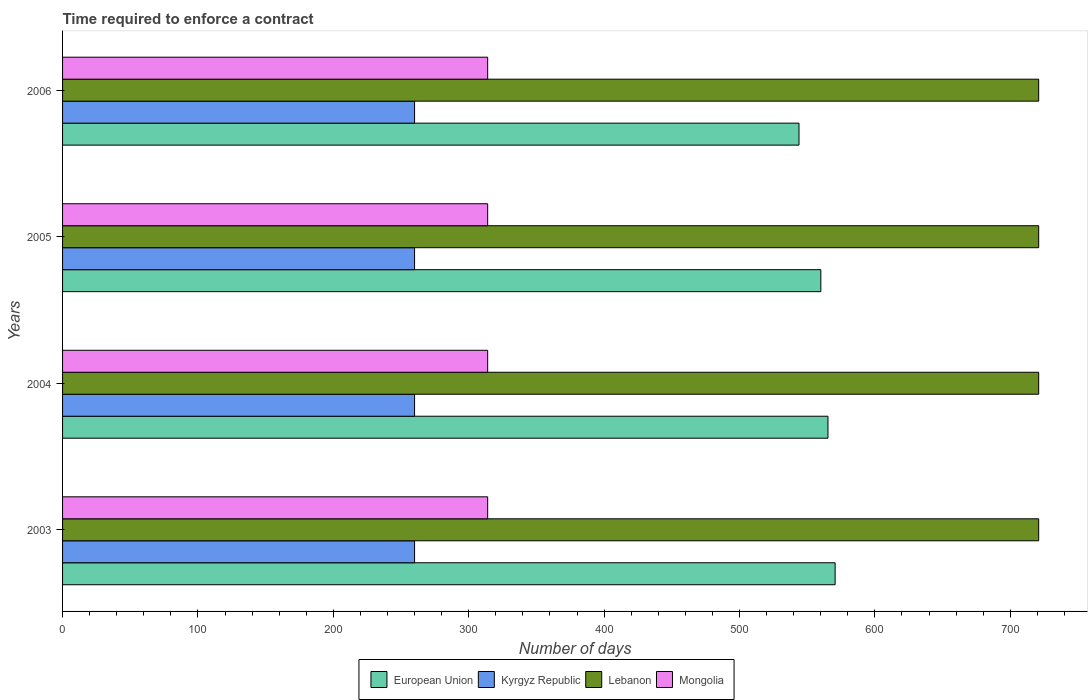How many different coloured bars are there?
Your answer should be very brief. 4. Are the number of bars per tick equal to the number of legend labels?
Your response must be concise. Yes. How many bars are there on the 4th tick from the bottom?
Make the answer very short. 4. What is the label of the 3rd group of bars from the top?
Ensure brevity in your answer.  2004. What is the number of days required to enforce a contract in European Union in 2005?
Your answer should be compact. 560.08. Across all years, what is the maximum number of days required to enforce a contract in European Union?
Make the answer very short. 570.64. Across all years, what is the minimum number of days required to enforce a contract in European Union?
Ensure brevity in your answer.  543.96. What is the total number of days required to enforce a contract in Lebanon in the graph?
Give a very brief answer. 2884. What is the difference between the number of days required to enforce a contract in European Union in 2003 and that in 2005?
Ensure brevity in your answer.  10.56. What is the difference between the number of days required to enforce a contract in Mongolia in 2006 and the number of days required to enforce a contract in European Union in 2003?
Keep it short and to the point. -256.64. What is the average number of days required to enforce a contract in European Union per year?
Your answer should be very brief. 560.01. In the year 2003, what is the difference between the number of days required to enforce a contract in Kyrgyz Republic and number of days required to enforce a contract in European Union?
Provide a succinct answer. -310.64. In how many years, is the number of days required to enforce a contract in European Union greater than 480 days?
Your answer should be compact. 4. Is the difference between the number of days required to enforce a contract in Kyrgyz Republic in 2004 and 2005 greater than the difference between the number of days required to enforce a contract in European Union in 2004 and 2005?
Offer a very short reply. No. What is the difference between the highest and the second highest number of days required to enforce a contract in Lebanon?
Your answer should be very brief. 0. What is the difference between the highest and the lowest number of days required to enforce a contract in Lebanon?
Give a very brief answer. 0. Is the sum of the number of days required to enforce a contract in Lebanon in 2003 and 2006 greater than the maximum number of days required to enforce a contract in Mongolia across all years?
Keep it short and to the point. Yes. Is it the case that in every year, the sum of the number of days required to enforce a contract in Kyrgyz Republic and number of days required to enforce a contract in Mongolia is greater than the sum of number of days required to enforce a contract in Lebanon and number of days required to enforce a contract in European Union?
Provide a succinct answer. No. What does the 2nd bar from the bottom in 2003 represents?
Give a very brief answer. Kyrgyz Republic. How many bars are there?
Ensure brevity in your answer.  16. Are all the bars in the graph horizontal?
Make the answer very short. Yes. How many years are there in the graph?
Offer a very short reply. 4. What is the difference between two consecutive major ticks on the X-axis?
Offer a very short reply. 100. Are the values on the major ticks of X-axis written in scientific E-notation?
Keep it short and to the point. No. How many legend labels are there?
Keep it short and to the point. 4. How are the legend labels stacked?
Make the answer very short. Horizontal. What is the title of the graph?
Your response must be concise. Time required to enforce a contract. What is the label or title of the X-axis?
Make the answer very short. Number of days. What is the label or title of the Y-axis?
Make the answer very short. Years. What is the Number of days in European Union in 2003?
Ensure brevity in your answer.  570.64. What is the Number of days of Kyrgyz Republic in 2003?
Offer a terse response. 260. What is the Number of days of Lebanon in 2003?
Provide a succinct answer. 721. What is the Number of days in Mongolia in 2003?
Your response must be concise. 314. What is the Number of days in European Union in 2004?
Provide a short and direct response. 565.36. What is the Number of days in Kyrgyz Republic in 2004?
Make the answer very short. 260. What is the Number of days in Lebanon in 2004?
Give a very brief answer. 721. What is the Number of days in Mongolia in 2004?
Your response must be concise. 314. What is the Number of days in European Union in 2005?
Provide a succinct answer. 560.08. What is the Number of days in Kyrgyz Republic in 2005?
Your response must be concise. 260. What is the Number of days in Lebanon in 2005?
Make the answer very short. 721. What is the Number of days in Mongolia in 2005?
Give a very brief answer. 314. What is the Number of days in European Union in 2006?
Provide a succinct answer. 543.96. What is the Number of days in Kyrgyz Republic in 2006?
Ensure brevity in your answer.  260. What is the Number of days of Lebanon in 2006?
Make the answer very short. 721. What is the Number of days of Mongolia in 2006?
Offer a very short reply. 314. Across all years, what is the maximum Number of days in European Union?
Your answer should be compact. 570.64. Across all years, what is the maximum Number of days of Kyrgyz Republic?
Give a very brief answer. 260. Across all years, what is the maximum Number of days of Lebanon?
Provide a short and direct response. 721. Across all years, what is the maximum Number of days in Mongolia?
Keep it short and to the point. 314. Across all years, what is the minimum Number of days of European Union?
Your answer should be very brief. 543.96. Across all years, what is the minimum Number of days in Kyrgyz Republic?
Offer a very short reply. 260. Across all years, what is the minimum Number of days of Lebanon?
Your answer should be very brief. 721. Across all years, what is the minimum Number of days of Mongolia?
Your response must be concise. 314. What is the total Number of days of European Union in the graph?
Your answer should be compact. 2240.04. What is the total Number of days of Kyrgyz Republic in the graph?
Provide a succinct answer. 1040. What is the total Number of days of Lebanon in the graph?
Provide a short and direct response. 2884. What is the total Number of days in Mongolia in the graph?
Provide a short and direct response. 1256. What is the difference between the Number of days in European Union in 2003 and that in 2004?
Make the answer very short. 5.28. What is the difference between the Number of days in Kyrgyz Republic in 2003 and that in 2004?
Offer a terse response. 0. What is the difference between the Number of days of Lebanon in 2003 and that in 2004?
Offer a very short reply. 0. What is the difference between the Number of days of Mongolia in 2003 and that in 2004?
Your answer should be compact. 0. What is the difference between the Number of days of European Union in 2003 and that in 2005?
Ensure brevity in your answer.  10.56. What is the difference between the Number of days in Lebanon in 2003 and that in 2005?
Your answer should be compact. 0. What is the difference between the Number of days of European Union in 2003 and that in 2006?
Offer a terse response. 26.68. What is the difference between the Number of days in European Union in 2004 and that in 2005?
Offer a very short reply. 5.28. What is the difference between the Number of days in Kyrgyz Republic in 2004 and that in 2005?
Offer a very short reply. 0. What is the difference between the Number of days of Lebanon in 2004 and that in 2005?
Give a very brief answer. 0. What is the difference between the Number of days of Mongolia in 2004 and that in 2005?
Give a very brief answer. 0. What is the difference between the Number of days in European Union in 2004 and that in 2006?
Keep it short and to the point. 21.4. What is the difference between the Number of days of Kyrgyz Republic in 2004 and that in 2006?
Provide a succinct answer. 0. What is the difference between the Number of days in Mongolia in 2004 and that in 2006?
Offer a very short reply. 0. What is the difference between the Number of days of European Union in 2005 and that in 2006?
Offer a very short reply. 16.12. What is the difference between the Number of days of Lebanon in 2005 and that in 2006?
Give a very brief answer. 0. What is the difference between the Number of days in Mongolia in 2005 and that in 2006?
Make the answer very short. 0. What is the difference between the Number of days of European Union in 2003 and the Number of days of Kyrgyz Republic in 2004?
Give a very brief answer. 310.64. What is the difference between the Number of days in European Union in 2003 and the Number of days in Lebanon in 2004?
Your response must be concise. -150.36. What is the difference between the Number of days of European Union in 2003 and the Number of days of Mongolia in 2004?
Offer a very short reply. 256.64. What is the difference between the Number of days of Kyrgyz Republic in 2003 and the Number of days of Lebanon in 2004?
Provide a short and direct response. -461. What is the difference between the Number of days in Kyrgyz Republic in 2003 and the Number of days in Mongolia in 2004?
Make the answer very short. -54. What is the difference between the Number of days of Lebanon in 2003 and the Number of days of Mongolia in 2004?
Give a very brief answer. 407. What is the difference between the Number of days of European Union in 2003 and the Number of days of Kyrgyz Republic in 2005?
Provide a succinct answer. 310.64. What is the difference between the Number of days of European Union in 2003 and the Number of days of Lebanon in 2005?
Make the answer very short. -150.36. What is the difference between the Number of days of European Union in 2003 and the Number of days of Mongolia in 2005?
Ensure brevity in your answer.  256.64. What is the difference between the Number of days of Kyrgyz Republic in 2003 and the Number of days of Lebanon in 2005?
Offer a terse response. -461. What is the difference between the Number of days of Kyrgyz Republic in 2003 and the Number of days of Mongolia in 2005?
Provide a short and direct response. -54. What is the difference between the Number of days in Lebanon in 2003 and the Number of days in Mongolia in 2005?
Give a very brief answer. 407. What is the difference between the Number of days in European Union in 2003 and the Number of days in Kyrgyz Republic in 2006?
Provide a short and direct response. 310.64. What is the difference between the Number of days of European Union in 2003 and the Number of days of Lebanon in 2006?
Ensure brevity in your answer.  -150.36. What is the difference between the Number of days of European Union in 2003 and the Number of days of Mongolia in 2006?
Your response must be concise. 256.64. What is the difference between the Number of days in Kyrgyz Republic in 2003 and the Number of days in Lebanon in 2006?
Ensure brevity in your answer.  -461. What is the difference between the Number of days in Kyrgyz Republic in 2003 and the Number of days in Mongolia in 2006?
Your response must be concise. -54. What is the difference between the Number of days of Lebanon in 2003 and the Number of days of Mongolia in 2006?
Your answer should be very brief. 407. What is the difference between the Number of days in European Union in 2004 and the Number of days in Kyrgyz Republic in 2005?
Offer a terse response. 305.36. What is the difference between the Number of days of European Union in 2004 and the Number of days of Lebanon in 2005?
Ensure brevity in your answer.  -155.64. What is the difference between the Number of days of European Union in 2004 and the Number of days of Mongolia in 2005?
Provide a short and direct response. 251.36. What is the difference between the Number of days in Kyrgyz Republic in 2004 and the Number of days in Lebanon in 2005?
Ensure brevity in your answer.  -461. What is the difference between the Number of days of Kyrgyz Republic in 2004 and the Number of days of Mongolia in 2005?
Provide a succinct answer. -54. What is the difference between the Number of days of Lebanon in 2004 and the Number of days of Mongolia in 2005?
Provide a short and direct response. 407. What is the difference between the Number of days in European Union in 2004 and the Number of days in Kyrgyz Republic in 2006?
Offer a very short reply. 305.36. What is the difference between the Number of days in European Union in 2004 and the Number of days in Lebanon in 2006?
Provide a succinct answer. -155.64. What is the difference between the Number of days of European Union in 2004 and the Number of days of Mongolia in 2006?
Provide a short and direct response. 251.36. What is the difference between the Number of days in Kyrgyz Republic in 2004 and the Number of days in Lebanon in 2006?
Provide a succinct answer. -461. What is the difference between the Number of days of Kyrgyz Republic in 2004 and the Number of days of Mongolia in 2006?
Ensure brevity in your answer.  -54. What is the difference between the Number of days in Lebanon in 2004 and the Number of days in Mongolia in 2006?
Your response must be concise. 407. What is the difference between the Number of days in European Union in 2005 and the Number of days in Kyrgyz Republic in 2006?
Offer a terse response. 300.08. What is the difference between the Number of days in European Union in 2005 and the Number of days in Lebanon in 2006?
Offer a very short reply. -160.92. What is the difference between the Number of days in European Union in 2005 and the Number of days in Mongolia in 2006?
Your response must be concise. 246.08. What is the difference between the Number of days in Kyrgyz Republic in 2005 and the Number of days in Lebanon in 2006?
Give a very brief answer. -461. What is the difference between the Number of days of Kyrgyz Republic in 2005 and the Number of days of Mongolia in 2006?
Keep it short and to the point. -54. What is the difference between the Number of days of Lebanon in 2005 and the Number of days of Mongolia in 2006?
Offer a terse response. 407. What is the average Number of days of European Union per year?
Give a very brief answer. 560.01. What is the average Number of days in Kyrgyz Republic per year?
Make the answer very short. 260. What is the average Number of days of Lebanon per year?
Your answer should be very brief. 721. What is the average Number of days in Mongolia per year?
Give a very brief answer. 314. In the year 2003, what is the difference between the Number of days of European Union and Number of days of Kyrgyz Republic?
Provide a short and direct response. 310.64. In the year 2003, what is the difference between the Number of days in European Union and Number of days in Lebanon?
Offer a very short reply. -150.36. In the year 2003, what is the difference between the Number of days of European Union and Number of days of Mongolia?
Your answer should be compact. 256.64. In the year 2003, what is the difference between the Number of days in Kyrgyz Republic and Number of days in Lebanon?
Make the answer very short. -461. In the year 2003, what is the difference between the Number of days of Kyrgyz Republic and Number of days of Mongolia?
Offer a very short reply. -54. In the year 2003, what is the difference between the Number of days in Lebanon and Number of days in Mongolia?
Make the answer very short. 407. In the year 2004, what is the difference between the Number of days in European Union and Number of days in Kyrgyz Republic?
Keep it short and to the point. 305.36. In the year 2004, what is the difference between the Number of days in European Union and Number of days in Lebanon?
Provide a short and direct response. -155.64. In the year 2004, what is the difference between the Number of days of European Union and Number of days of Mongolia?
Give a very brief answer. 251.36. In the year 2004, what is the difference between the Number of days of Kyrgyz Republic and Number of days of Lebanon?
Offer a very short reply. -461. In the year 2004, what is the difference between the Number of days of Kyrgyz Republic and Number of days of Mongolia?
Make the answer very short. -54. In the year 2004, what is the difference between the Number of days of Lebanon and Number of days of Mongolia?
Keep it short and to the point. 407. In the year 2005, what is the difference between the Number of days of European Union and Number of days of Kyrgyz Republic?
Keep it short and to the point. 300.08. In the year 2005, what is the difference between the Number of days in European Union and Number of days in Lebanon?
Ensure brevity in your answer.  -160.92. In the year 2005, what is the difference between the Number of days in European Union and Number of days in Mongolia?
Provide a succinct answer. 246.08. In the year 2005, what is the difference between the Number of days of Kyrgyz Republic and Number of days of Lebanon?
Your answer should be compact. -461. In the year 2005, what is the difference between the Number of days in Kyrgyz Republic and Number of days in Mongolia?
Keep it short and to the point. -54. In the year 2005, what is the difference between the Number of days in Lebanon and Number of days in Mongolia?
Give a very brief answer. 407. In the year 2006, what is the difference between the Number of days of European Union and Number of days of Kyrgyz Republic?
Keep it short and to the point. 283.96. In the year 2006, what is the difference between the Number of days in European Union and Number of days in Lebanon?
Provide a short and direct response. -177.04. In the year 2006, what is the difference between the Number of days in European Union and Number of days in Mongolia?
Your answer should be very brief. 229.96. In the year 2006, what is the difference between the Number of days in Kyrgyz Republic and Number of days in Lebanon?
Give a very brief answer. -461. In the year 2006, what is the difference between the Number of days in Kyrgyz Republic and Number of days in Mongolia?
Your answer should be compact. -54. In the year 2006, what is the difference between the Number of days of Lebanon and Number of days of Mongolia?
Offer a very short reply. 407. What is the ratio of the Number of days in European Union in 2003 to that in 2004?
Provide a short and direct response. 1.01. What is the ratio of the Number of days in Kyrgyz Republic in 2003 to that in 2004?
Keep it short and to the point. 1. What is the ratio of the Number of days of Lebanon in 2003 to that in 2004?
Offer a very short reply. 1. What is the ratio of the Number of days in Mongolia in 2003 to that in 2004?
Make the answer very short. 1. What is the ratio of the Number of days of European Union in 2003 to that in 2005?
Keep it short and to the point. 1.02. What is the ratio of the Number of days in Mongolia in 2003 to that in 2005?
Your answer should be very brief. 1. What is the ratio of the Number of days in European Union in 2003 to that in 2006?
Provide a succinct answer. 1.05. What is the ratio of the Number of days of Kyrgyz Republic in 2003 to that in 2006?
Keep it short and to the point. 1. What is the ratio of the Number of days of Lebanon in 2003 to that in 2006?
Your answer should be compact. 1. What is the ratio of the Number of days in Mongolia in 2003 to that in 2006?
Your answer should be compact. 1. What is the ratio of the Number of days in European Union in 2004 to that in 2005?
Give a very brief answer. 1.01. What is the ratio of the Number of days in Lebanon in 2004 to that in 2005?
Provide a short and direct response. 1. What is the ratio of the Number of days of Mongolia in 2004 to that in 2005?
Your answer should be very brief. 1. What is the ratio of the Number of days in European Union in 2004 to that in 2006?
Your response must be concise. 1.04. What is the ratio of the Number of days in Mongolia in 2004 to that in 2006?
Your response must be concise. 1. What is the ratio of the Number of days in European Union in 2005 to that in 2006?
Provide a short and direct response. 1.03. What is the ratio of the Number of days of Lebanon in 2005 to that in 2006?
Ensure brevity in your answer.  1. What is the difference between the highest and the second highest Number of days in European Union?
Offer a very short reply. 5.28. What is the difference between the highest and the second highest Number of days in Lebanon?
Make the answer very short. 0. What is the difference between the highest and the second highest Number of days in Mongolia?
Your answer should be very brief. 0. What is the difference between the highest and the lowest Number of days of European Union?
Offer a very short reply. 26.68. 